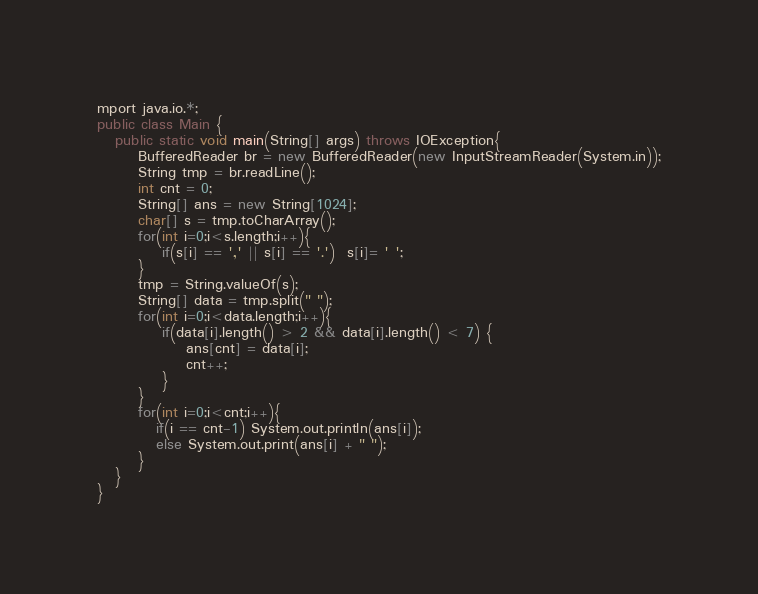Convert code to text. <code><loc_0><loc_0><loc_500><loc_500><_Java_>mport java.io.*;
public class Main {
   public static void main(String[] args) throws IOException{
       BufferedReader br = new BufferedReader(new InputStreamReader(System.in));
       String tmp = br.readLine();
       int cnt = 0;
       String[] ans = new String[1024];
       char[] s = tmp.toCharArray();
       for(int i=0;i<s.length;i++){
           if(s[i] == ',' || s[i] == '.')  s[i]= ' ';
       }
       tmp = String.valueOf(s);
       String[] data = tmp.split(" ");
       for(int i=0;i<data.length;i++){
           if(data[i].length() > 2 && data[i].length() < 7) {
               ans[cnt] = data[i];
               cnt++;
           }
       }
       for(int i=0;i<cnt;i++){
          if(i == cnt-1) System.out.println(ans[i]);
          else System.out.print(ans[i] + " ");
       }
   }
}</code> 